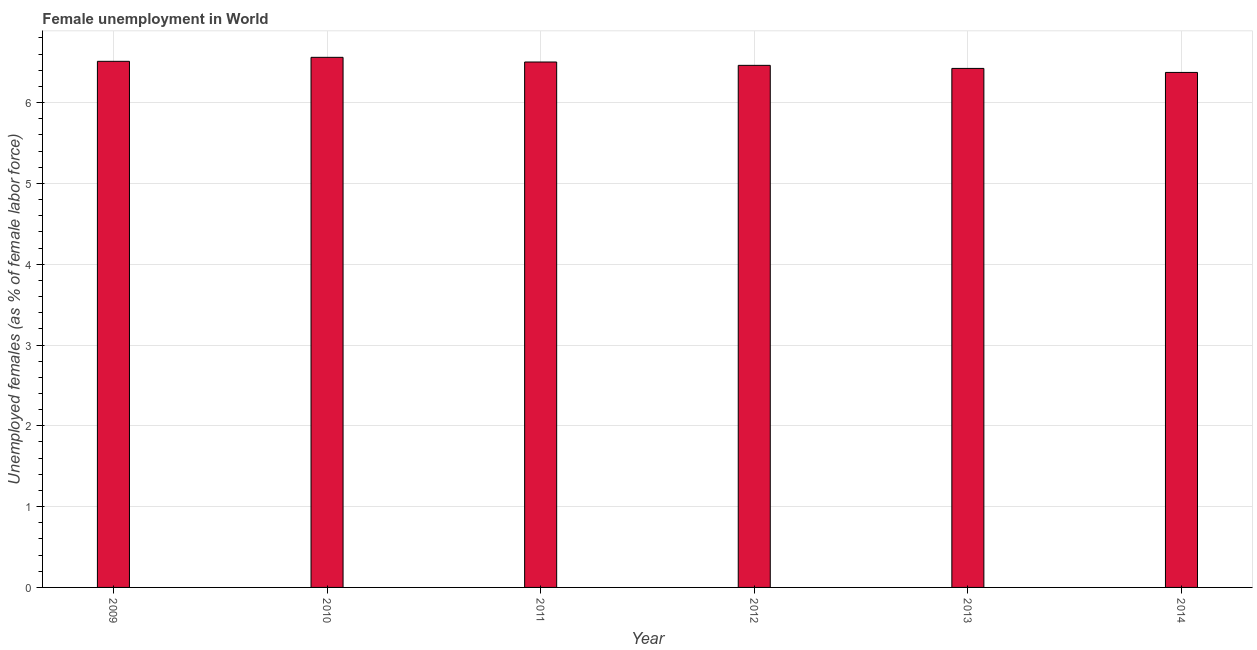Does the graph contain any zero values?
Keep it short and to the point. No. What is the title of the graph?
Offer a terse response. Female unemployment in World. What is the label or title of the Y-axis?
Your answer should be very brief. Unemployed females (as % of female labor force). What is the unemployed females population in 2013?
Keep it short and to the point. 6.42. Across all years, what is the maximum unemployed females population?
Provide a short and direct response. 6.56. Across all years, what is the minimum unemployed females population?
Your answer should be compact. 6.37. In which year was the unemployed females population minimum?
Ensure brevity in your answer.  2014. What is the sum of the unemployed females population?
Offer a very short reply. 38.83. What is the difference between the unemployed females population in 2010 and 2011?
Make the answer very short. 0.06. What is the average unemployed females population per year?
Your answer should be compact. 6.47. What is the median unemployed females population?
Make the answer very short. 6.48. What is the ratio of the unemployed females population in 2011 to that in 2012?
Offer a terse response. 1.01. Is the difference between the unemployed females population in 2013 and 2014 greater than the difference between any two years?
Make the answer very short. No. What is the difference between the highest and the second highest unemployed females population?
Provide a short and direct response. 0.05. What is the difference between the highest and the lowest unemployed females population?
Your answer should be compact. 0.19. Are all the bars in the graph horizontal?
Your answer should be compact. No. How many years are there in the graph?
Your answer should be very brief. 6. What is the difference between two consecutive major ticks on the Y-axis?
Provide a short and direct response. 1. What is the Unemployed females (as % of female labor force) of 2009?
Ensure brevity in your answer.  6.51. What is the Unemployed females (as % of female labor force) in 2010?
Offer a very short reply. 6.56. What is the Unemployed females (as % of female labor force) of 2011?
Offer a very short reply. 6.5. What is the Unemployed females (as % of female labor force) of 2012?
Provide a succinct answer. 6.46. What is the Unemployed females (as % of female labor force) of 2013?
Offer a terse response. 6.42. What is the Unemployed females (as % of female labor force) of 2014?
Your answer should be compact. 6.37. What is the difference between the Unemployed females (as % of female labor force) in 2009 and 2010?
Your answer should be compact. -0.05. What is the difference between the Unemployed females (as % of female labor force) in 2009 and 2011?
Offer a very short reply. 0.01. What is the difference between the Unemployed females (as % of female labor force) in 2009 and 2012?
Provide a short and direct response. 0.05. What is the difference between the Unemployed females (as % of female labor force) in 2009 and 2013?
Your answer should be very brief. 0.09. What is the difference between the Unemployed females (as % of female labor force) in 2009 and 2014?
Give a very brief answer. 0.14. What is the difference between the Unemployed females (as % of female labor force) in 2010 and 2011?
Keep it short and to the point. 0.06. What is the difference between the Unemployed females (as % of female labor force) in 2010 and 2012?
Your response must be concise. 0.1. What is the difference between the Unemployed females (as % of female labor force) in 2010 and 2013?
Offer a very short reply. 0.14. What is the difference between the Unemployed females (as % of female labor force) in 2010 and 2014?
Provide a short and direct response. 0.19. What is the difference between the Unemployed females (as % of female labor force) in 2011 and 2012?
Ensure brevity in your answer.  0.04. What is the difference between the Unemployed females (as % of female labor force) in 2011 and 2013?
Make the answer very short. 0.08. What is the difference between the Unemployed females (as % of female labor force) in 2011 and 2014?
Give a very brief answer. 0.13. What is the difference between the Unemployed females (as % of female labor force) in 2012 and 2013?
Give a very brief answer. 0.04. What is the difference between the Unemployed females (as % of female labor force) in 2012 and 2014?
Your answer should be very brief. 0.09. What is the difference between the Unemployed females (as % of female labor force) in 2013 and 2014?
Make the answer very short. 0.05. What is the ratio of the Unemployed females (as % of female labor force) in 2009 to that in 2011?
Ensure brevity in your answer.  1. What is the ratio of the Unemployed females (as % of female labor force) in 2009 to that in 2012?
Offer a very short reply. 1.01. What is the ratio of the Unemployed females (as % of female labor force) in 2010 to that in 2011?
Offer a very short reply. 1.01. What is the ratio of the Unemployed females (as % of female labor force) in 2010 to that in 2012?
Offer a terse response. 1.01. What is the ratio of the Unemployed females (as % of female labor force) in 2010 to that in 2014?
Your answer should be compact. 1.03. What is the ratio of the Unemployed females (as % of female labor force) in 2011 to that in 2014?
Provide a short and direct response. 1.02. 